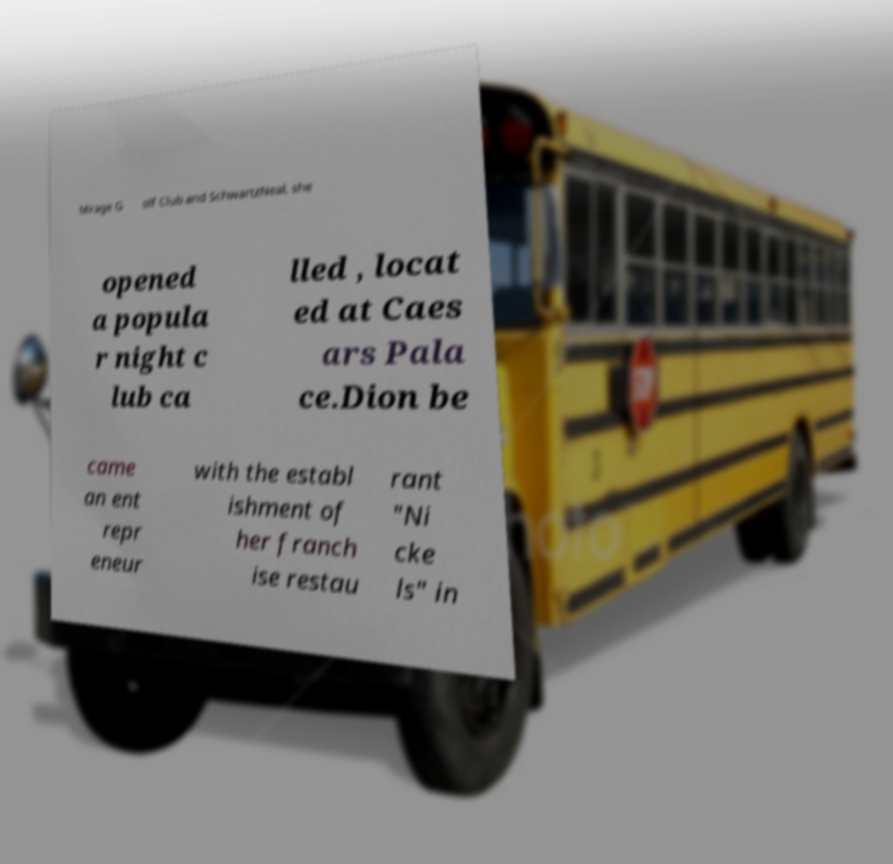Can you accurately transcribe the text from the provided image for me? Mirage G olf Club and SchwartzNeal, she opened a popula r night c lub ca lled , locat ed at Caes ars Pala ce.Dion be came an ent repr eneur with the establ ishment of her franch ise restau rant "Ni cke ls" in 